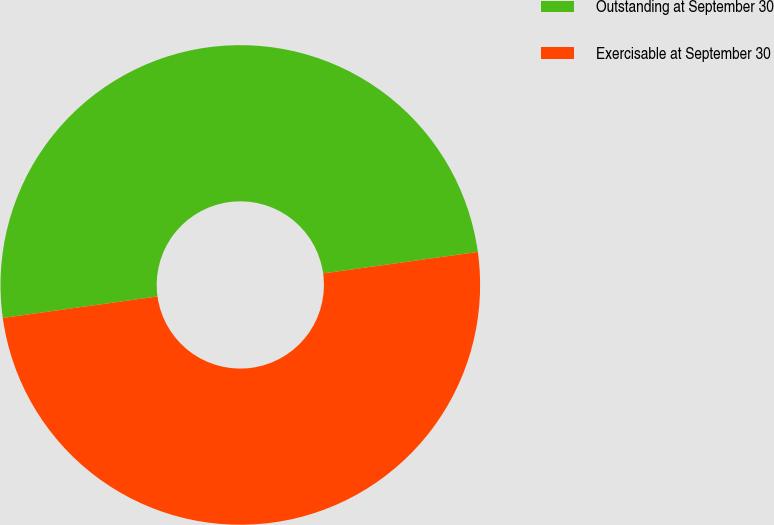Convert chart to OTSL. <chart><loc_0><loc_0><loc_500><loc_500><pie_chart><fcel>Outstanding at September 30<fcel>Exercisable at September 30<nl><fcel>50.0%<fcel>50.0%<nl></chart> 